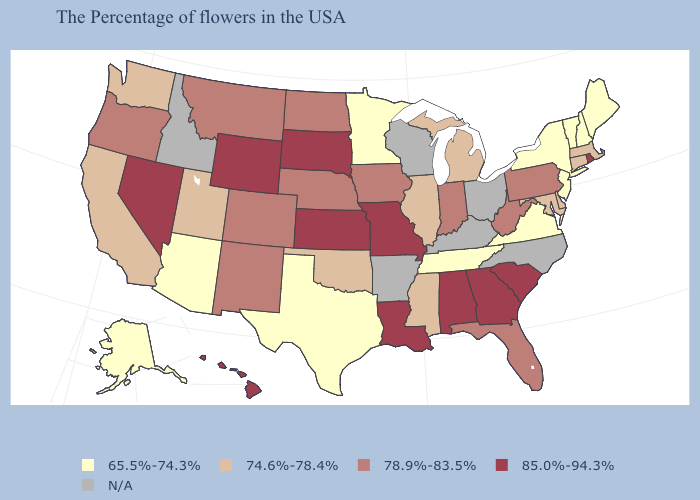Among the states that border South Dakota , which have the lowest value?
Keep it brief. Minnesota. Name the states that have a value in the range N/A?
Keep it brief. North Carolina, Ohio, Kentucky, Wisconsin, Arkansas, Idaho. Name the states that have a value in the range N/A?
Concise answer only. North Carolina, Ohio, Kentucky, Wisconsin, Arkansas, Idaho. What is the highest value in the USA?
Quick response, please. 85.0%-94.3%. Name the states that have a value in the range 78.9%-83.5%?
Quick response, please. Pennsylvania, West Virginia, Florida, Indiana, Iowa, Nebraska, North Dakota, Colorado, New Mexico, Montana, Oregon. Does Minnesota have the highest value in the USA?
Concise answer only. No. Does Oklahoma have the lowest value in the USA?
Short answer required. No. What is the lowest value in the USA?
Answer briefly. 65.5%-74.3%. What is the highest value in the USA?
Answer briefly. 85.0%-94.3%. What is the value of Connecticut?
Be succinct. 74.6%-78.4%. What is the value of West Virginia?
Short answer required. 78.9%-83.5%. What is the value of Delaware?
Answer briefly. 74.6%-78.4%. Does South Dakota have the highest value in the MidWest?
Concise answer only. Yes. 